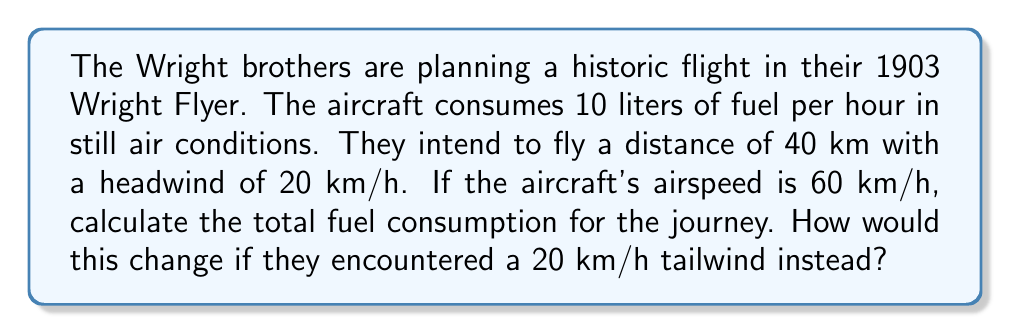Give your solution to this math problem. Let's approach this step-by-step:

1. Calculate the ground speed with headwind:
   Ground speed = Airspeed - Headwind
   $$ v_{ground} = 60 \text{ km/h} - 20 \text{ km/h} = 40 \text{ km/h} $$

2. Calculate the flight time with headwind:
   $$ t_{headwind} = \frac{\text{Distance}}{\text{Ground speed}} = \frac{40 \text{ km}}{40 \text{ km/h}} = 1 \text{ hour} $$

3. Calculate fuel consumption with headwind:
   $$ \text{Fuel}_{headwind} = 10 \text{ L/h} \times 1 \text{ h} = 10 \text{ L} $$

4. For tailwind scenario, calculate new ground speed:
   Ground speed = Airspeed + Tailwind
   $$ v_{ground} = 60 \text{ km/h} + 20 \text{ km/h} = 80 \text{ km/h} $$

5. Calculate flight time with tailwind:
   $$ t_{tailwind} = \frac{\text{Distance}}{\text{Ground speed}} = \frac{40 \text{ km}}{80 \text{ km/h}} = 0.5 \text{ hours} $$

6. Calculate fuel consumption with tailwind:
   $$ \text{Fuel}_{tailwind} = 10 \text{ L/h} \times 0.5 \text{ h} = 5 \text{ L} $$

The difference in fuel consumption:
$$ \Delta \text{Fuel} = \text{Fuel}_{headwind} - \text{Fuel}_{tailwind} = 10 \text{ L} - 5 \text{ L} = 5 \text{ L} $$
Answer: 10 L with headwind, 5 L with tailwind; 5 L difference 